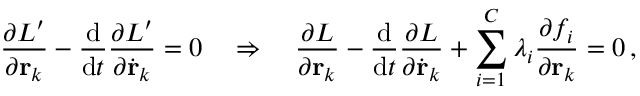Convert formula to latex. <formula><loc_0><loc_0><loc_500><loc_500>{ \frac { \partial L ^ { \prime } } { \partial r _ { k } } } - { \frac { d } { d t } } { \frac { \partial L ^ { \prime } } { \partial { \dot { r } } _ { k } } } = 0 \quad \Rightarrow \quad \frac { \partial L } { \partial r _ { k } } - { \frac { d } { d t } } { \frac { \partial L } { \partial { \dot { r } } _ { k } } } + \sum _ { i = 1 } ^ { C } \lambda _ { i } { \frac { \partial f _ { i } } { \partial r _ { k } } } = 0 \, ,</formula> 